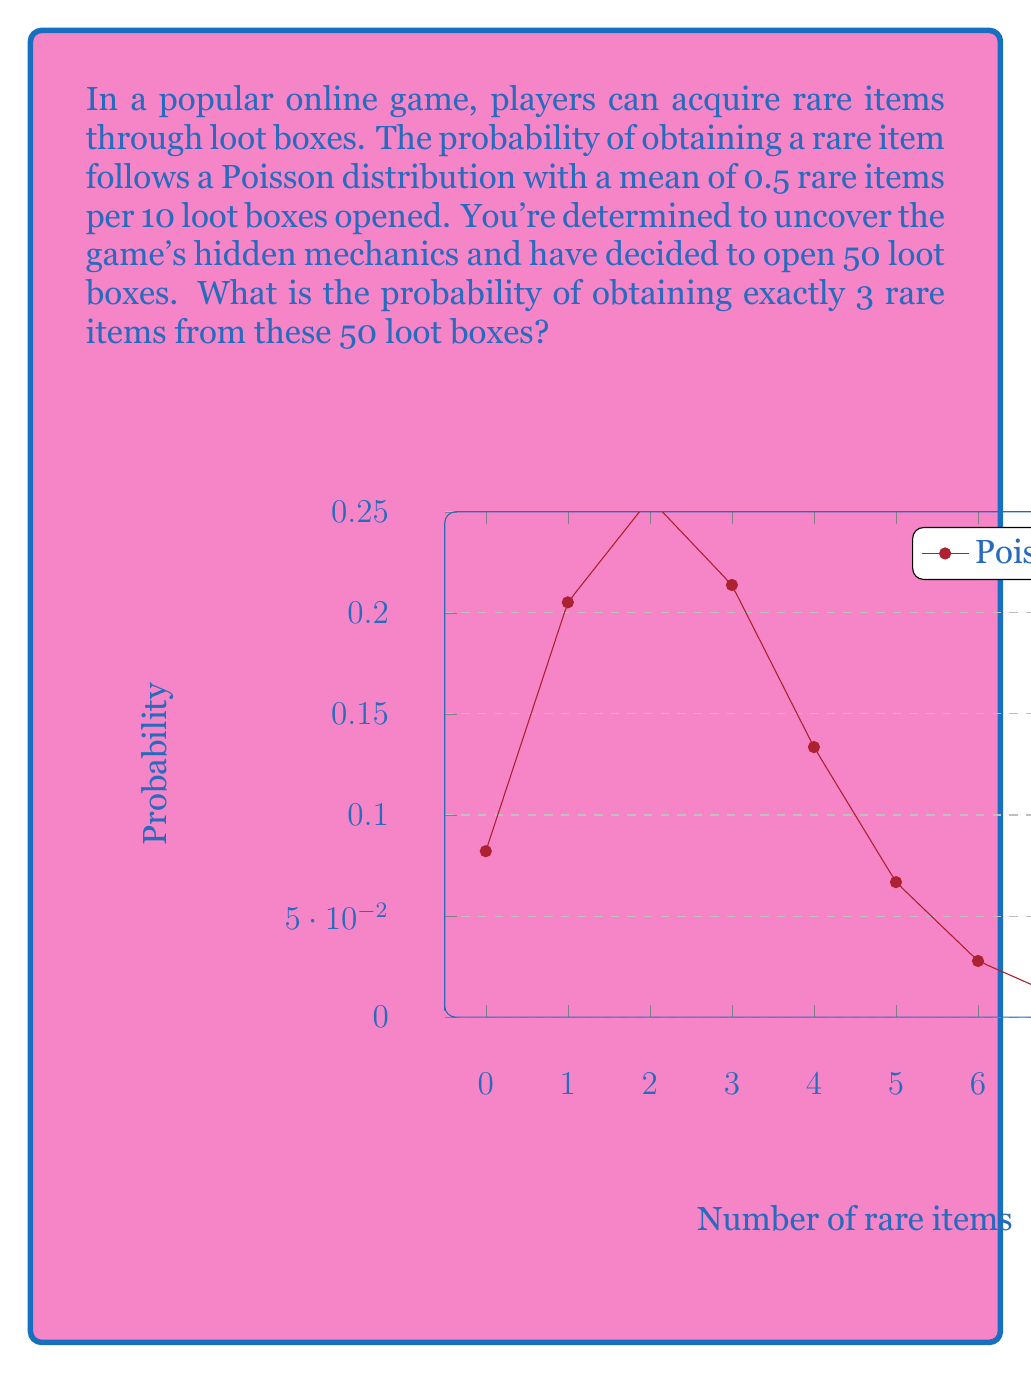Solve this math problem. Let's approach this step-by-step:

1) First, we need to determine the mean (λ) for our Poisson distribution:
   - We're given 0.5 rare items per 10 loot boxes
   - We're opening 50 loot boxes
   - So, λ = 0.5 * (50/10) = 2.5

2) The Poisson probability mass function is:

   $$P(X = k) = \frac{e^{-\lambda} \lambda^k}{k!}$$

   Where:
   - e is Euler's number (approximately 2.71828)
   - λ is the mean
   - k is the number of occurrences we're interested in (in this case, 3)

3) Let's plug in our values:

   $$P(X = 3) = \frac{e^{-2.5} 2.5^3}{3!}$$

4) Now let's calculate:
   
   $$P(X = 3) = \frac{e^{-2.5} * 15.625}{6}$$

5) Using a calculator:

   $$P(X = 3) = \frac{0.082085 * 15.625}{6} = 0.2137$$

6) Converting to a percentage:

   0.2137 * 100 = 21.37%

Therefore, the probability of obtaining exactly 3 rare items from 50 loot boxes is approximately 21.37%.
Answer: 21.37% 